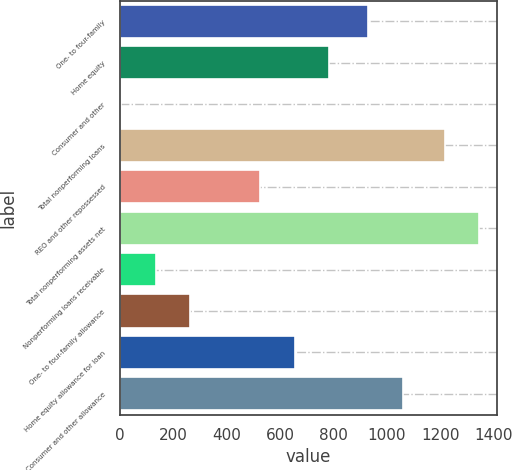Convert chart to OTSL. <chart><loc_0><loc_0><loc_500><loc_500><bar_chart><fcel>One- to four-family<fcel>Home equity<fcel>Consumer and other<fcel>Total nonperforming loans<fcel>REO and other repossessed<fcel>Total nonperforming assets net<fcel>Nonperforming loans receivable<fcel>One- to four-family allowance<fcel>Home equity allowance for loan<fcel>Consumer and other allowance<nl><fcel>930.2<fcel>784.02<fcel>4.5<fcel>1216.1<fcel>524.18<fcel>1346.02<fcel>134.42<fcel>264.34<fcel>654.1<fcel>1060.12<nl></chart> 